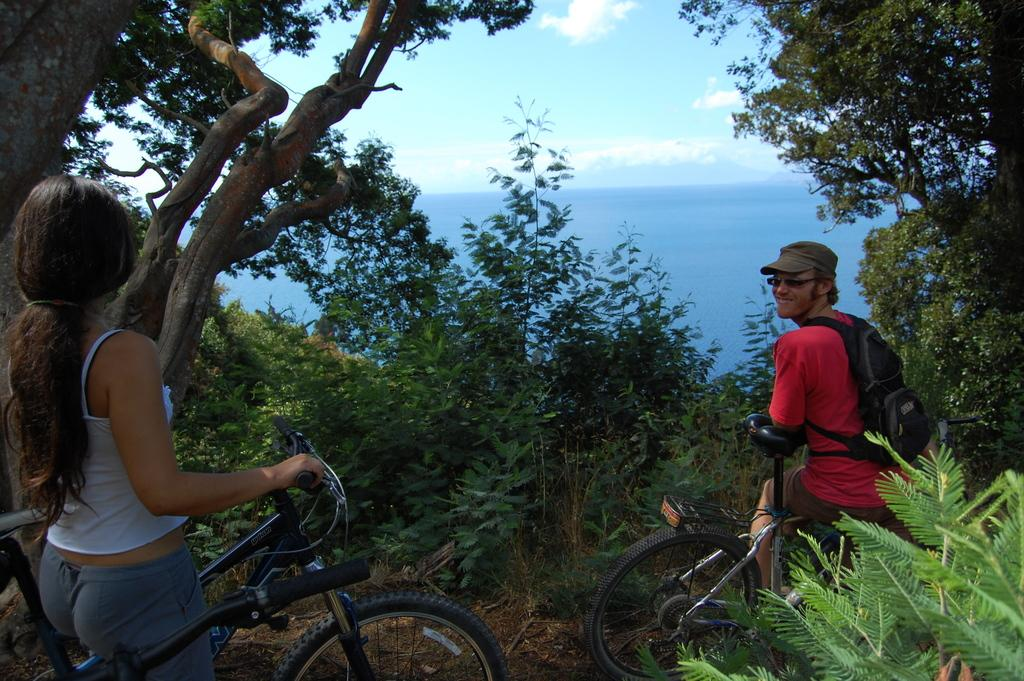How many people are in the image? There are two people in the image. Can you describe the individuals in the image? One person is a man, and the other person is a woman. What are the two people doing in the image? The two people are riding a bicycle. What can be seen in the background of the image? There is a tree and water visible in the image. How would you describe the weather based on the image? The sky is cloudy in the image. What type of scissors can be seen in the image? There are no scissors present in the image. What educational institution can be seen in the image? There is no educational institution present in the image. 